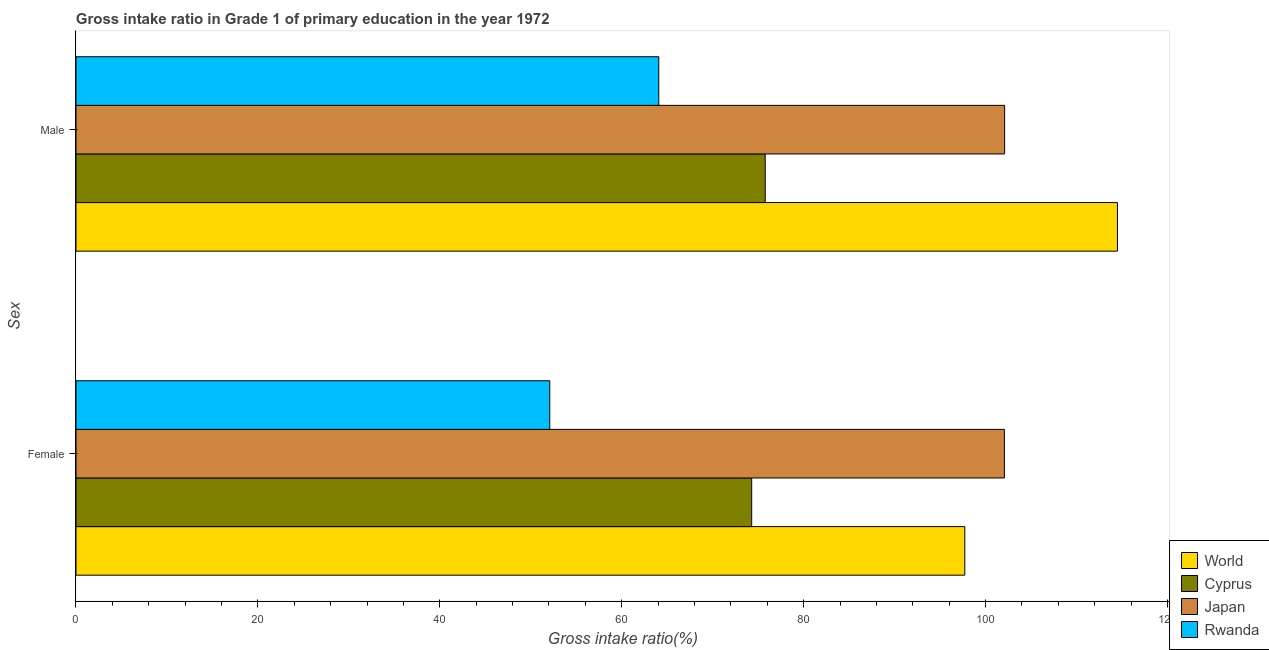How many different coloured bars are there?
Provide a short and direct response. 4. How many bars are there on the 2nd tick from the top?
Offer a very short reply. 4. What is the label of the 1st group of bars from the top?
Offer a very short reply. Male. What is the gross intake ratio(male) in Rwanda?
Your answer should be compact. 64.07. Across all countries, what is the maximum gross intake ratio(male)?
Provide a succinct answer. 114.5. Across all countries, what is the minimum gross intake ratio(male)?
Give a very brief answer. 64.07. In which country was the gross intake ratio(female) maximum?
Keep it short and to the point. Japan. In which country was the gross intake ratio(female) minimum?
Give a very brief answer. Rwanda. What is the total gross intake ratio(male) in the graph?
Make the answer very short. 356.43. What is the difference between the gross intake ratio(male) in Cyprus and that in World?
Offer a terse response. -38.73. What is the difference between the gross intake ratio(female) in Cyprus and the gross intake ratio(male) in Japan?
Ensure brevity in your answer.  -27.81. What is the average gross intake ratio(female) per country?
Provide a succinct answer. 81.54. What is the difference between the gross intake ratio(male) and gross intake ratio(female) in Rwanda?
Offer a terse response. 11.99. What is the ratio of the gross intake ratio(female) in World to that in Cyprus?
Provide a short and direct response. 1.32. In how many countries, is the gross intake ratio(male) greater than the average gross intake ratio(male) taken over all countries?
Give a very brief answer. 2. What does the 1st bar from the top in Male represents?
Your response must be concise. Rwanda. How many bars are there?
Keep it short and to the point. 8. Are all the bars in the graph horizontal?
Offer a terse response. Yes. How many countries are there in the graph?
Keep it short and to the point. 4. Are the values on the major ticks of X-axis written in scientific E-notation?
Offer a very short reply. No. Does the graph contain grids?
Your response must be concise. No. How many legend labels are there?
Offer a very short reply. 4. What is the title of the graph?
Provide a succinct answer. Gross intake ratio in Grade 1 of primary education in the year 1972. What is the label or title of the X-axis?
Keep it short and to the point. Gross intake ratio(%). What is the label or title of the Y-axis?
Give a very brief answer. Sex. What is the Gross intake ratio(%) of World in Female?
Ensure brevity in your answer.  97.72. What is the Gross intake ratio(%) in Cyprus in Female?
Make the answer very short. 74.29. What is the Gross intake ratio(%) of Japan in Female?
Give a very brief answer. 102.07. What is the Gross intake ratio(%) of Rwanda in Female?
Keep it short and to the point. 52.09. What is the Gross intake ratio(%) of World in Male?
Make the answer very short. 114.5. What is the Gross intake ratio(%) of Cyprus in Male?
Provide a short and direct response. 75.77. What is the Gross intake ratio(%) of Japan in Male?
Your answer should be very brief. 102.09. What is the Gross intake ratio(%) in Rwanda in Male?
Offer a terse response. 64.07. Across all Sex, what is the maximum Gross intake ratio(%) of World?
Offer a terse response. 114.5. Across all Sex, what is the maximum Gross intake ratio(%) of Cyprus?
Ensure brevity in your answer.  75.77. Across all Sex, what is the maximum Gross intake ratio(%) of Japan?
Offer a terse response. 102.09. Across all Sex, what is the maximum Gross intake ratio(%) of Rwanda?
Provide a short and direct response. 64.07. Across all Sex, what is the minimum Gross intake ratio(%) of World?
Offer a very short reply. 97.72. Across all Sex, what is the minimum Gross intake ratio(%) in Cyprus?
Provide a succinct answer. 74.29. Across all Sex, what is the minimum Gross intake ratio(%) of Japan?
Ensure brevity in your answer.  102.07. Across all Sex, what is the minimum Gross intake ratio(%) of Rwanda?
Give a very brief answer. 52.09. What is the total Gross intake ratio(%) of World in the graph?
Keep it short and to the point. 212.21. What is the total Gross intake ratio(%) of Cyprus in the graph?
Your response must be concise. 150.06. What is the total Gross intake ratio(%) of Japan in the graph?
Make the answer very short. 204.16. What is the total Gross intake ratio(%) in Rwanda in the graph?
Give a very brief answer. 116.16. What is the difference between the Gross intake ratio(%) of World in Female and that in Male?
Offer a very short reply. -16.78. What is the difference between the Gross intake ratio(%) of Cyprus in Female and that in Male?
Your answer should be compact. -1.49. What is the difference between the Gross intake ratio(%) of Japan in Female and that in Male?
Provide a short and direct response. -0.02. What is the difference between the Gross intake ratio(%) in Rwanda in Female and that in Male?
Offer a very short reply. -11.99. What is the difference between the Gross intake ratio(%) in World in Female and the Gross intake ratio(%) in Cyprus in Male?
Give a very brief answer. 21.95. What is the difference between the Gross intake ratio(%) in World in Female and the Gross intake ratio(%) in Japan in Male?
Offer a terse response. -4.38. What is the difference between the Gross intake ratio(%) in World in Female and the Gross intake ratio(%) in Rwanda in Male?
Make the answer very short. 33.65. What is the difference between the Gross intake ratio(%) of Cyprus in Female and the Gross intake ratio(%) of Japan in Male?
Provide a succinct answer. -27.81. What is the difference between the Gross intake ratio(%) in Cyprus in Female and the Gross intake ratio(%) in Rwanda in Male?
Offer a very short reply. 10.21. What is the difference between the Gross intake ratio(%) in Japan in Female and the Gross intake ratio(%) in Rwanda in Male?
Offer a terse response. 38. What is the average Gross intake ratio(%) in World per Sex?
Keep it short and to the point. 106.11. What is the average Gross intake ratio(%) of Cyprus per Sex?
Provide a short and direct response. 75.03. What is the average Gross intake ratio(%) of Japan per Sex?
Provide a succinct answer. 102.08. What is the average Gross intake ratio(%) of Rwanda per Sex?
Provide a succinct answer. 58.08. What is the difference between the Gross intake ratio(%) in World and Gross intake ratio(%) in Cyprus in Female?
Offer a terse response. 23.43. What is the difference between the Gross intake ratio(%) of World and Gross intake ratio(%) of Japan in Female?
Offer a terse response. -4.35. What is the difference between the Gross intake ratio(%) in World and Gross intake ratio(%) in Rwanda in Female?
Provide a succinct answer. 45.63. What is the difference between the Gross intake ratio(%) in Cyprus and Gross intake ratio(%) in Japan in Female?
Make the answer very short. -27.78. What is the difference between the Gross intake ratio(%) in Cyprus and Gross intake ratio(%) in Rwanda in Female?
Make the answer very short. 22.2. What is the difference between the Gross intake ratio(%) of Japan and Gross intake ratio(%) of Rwanda in Female?
Your answer should be compact. 49.98. What is the difference between the Gross intake ratio(%) of World and Gross intake ratio(%) of Cyprus in Male?
Your answer should be very brief. 38.73. What is the difference between the Gross intake ratio(%) of World and Gross intake ratio(%) of Japan in Male?
Give a very brief answer. 12.4. What is the difference between the Gross intake ratio(%) in World and Gross intake ratio(%) in Rwanda in Male?
Your answer should be compact. 50.43. What is the difference between the Gross intake ratio(%) of Cyprus and Gross intake ratio(%) of Japan in Male?
Keep it short and to the point. -26.32. What is the difference between the Gross intake ratio(%) in Cyprus and Gross intake ratio(%) in Rwanda in Male?
Your answer should be very brief. 11.7. What is the difference between the Gross intake ratio(%) of Japan and Gross intake ratio(%) of Rwanda in Male?
Make the answer very short. 38.02. What is the ratio of the Gross intake ratio(%) in World in Female to that in Male?
Provide a short and direct response. 0.85. What is the ratio of the Gross intake ratio(%) of Cyprus in Female to that in Male?
Keep it short and to the point. 0.98. What is the ratio of the Gross intake ratio(%) of Rwanda in Female to that in Male?
Offer a very short reply. 0.81. What is the difference between the highest and the second highest Gross intake ratio(%) in World?
Give a very brief answer. 16.78. What is the difference between the highest and the second highest Gross intake ratio(%) in Cyprus?
Provide a succinct answer. 1.49. What is the difference between the highest and the second highest Gross intake ratio(%) in Japan?
Your response must be concise. 0.02. What is the difference between the highest and the second highest Gross intake ratio(%) of Rwanda?
Provide a short and direct response. 11.99. What is the difference between the highest and the lowest Gross intake ratio(%) in World?
Provide a short and direct response. 16.78. What is the difference between the highest and the lowest Gross intake ratio(%) of Cyprus?
Your answer should be very brief. 1.49. What is the difference between the highest and the lowest Gross intake ratio(%) of Japan?
Your response must be concise. 0.02. What is the difference between the highest and the lowest Gross intake ratio(%) of Rwanda?
Make the answer very short. 11.99. 